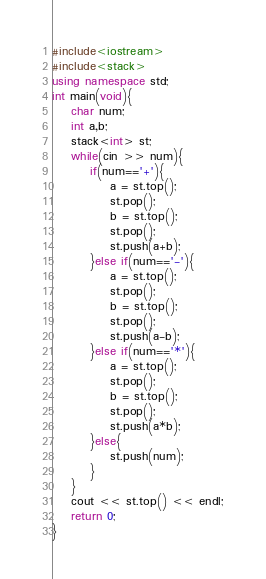Convert code to text. <code><loc_0><loc_0><loc_500><loc_500><_C++_>#include<iostream>
#include<stack>
using namespace std;
int main(void){
    char num;
    int a,b;
    stack<int> st;
    while(cin >> num){
        if(num=='+'){
            a = st.top();
            st.pop();
            b = st.top();
            st.pop();
            st.push(a+b);
        }else if(num=='-'){
            a = st.top();
            st.pop();
            b = st.top();
            st.pop();
            st.push(a-b);
        }else if(num=='*'){
            a = st.top();
            st.pop();
            b = st.top();
            st.pop();
            st.push(a*b);
        }else{
            st.push(num);
        }
    }
    cout << st.top() << endl;
    return 0;
}

</code> 